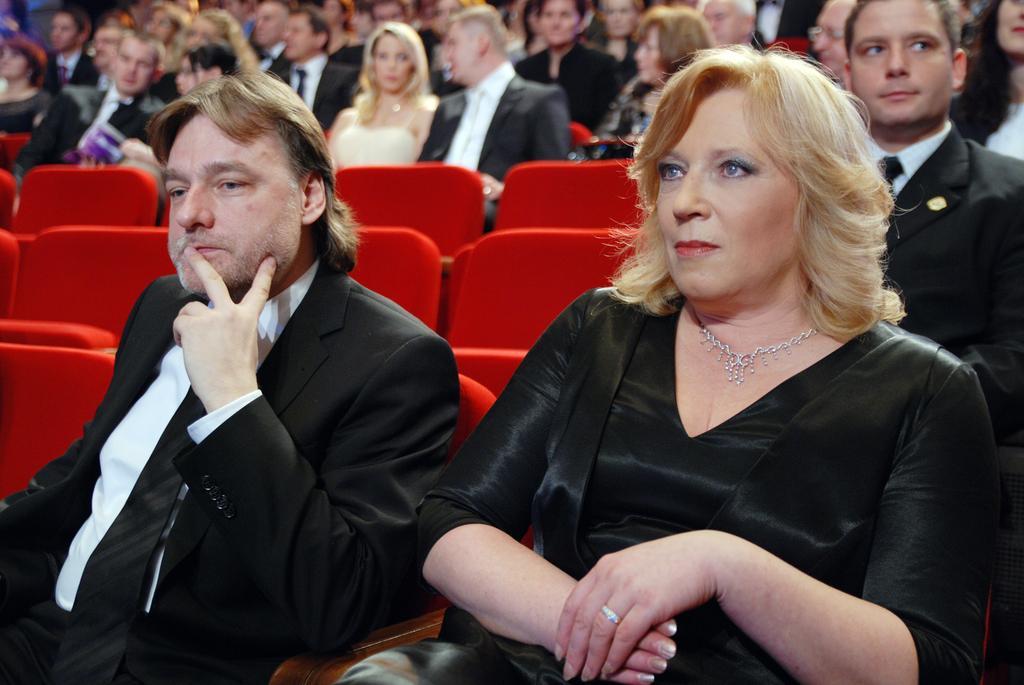How would you summarize this image in a sentence or two? In this image we can see many persons sitting on the chairs. 